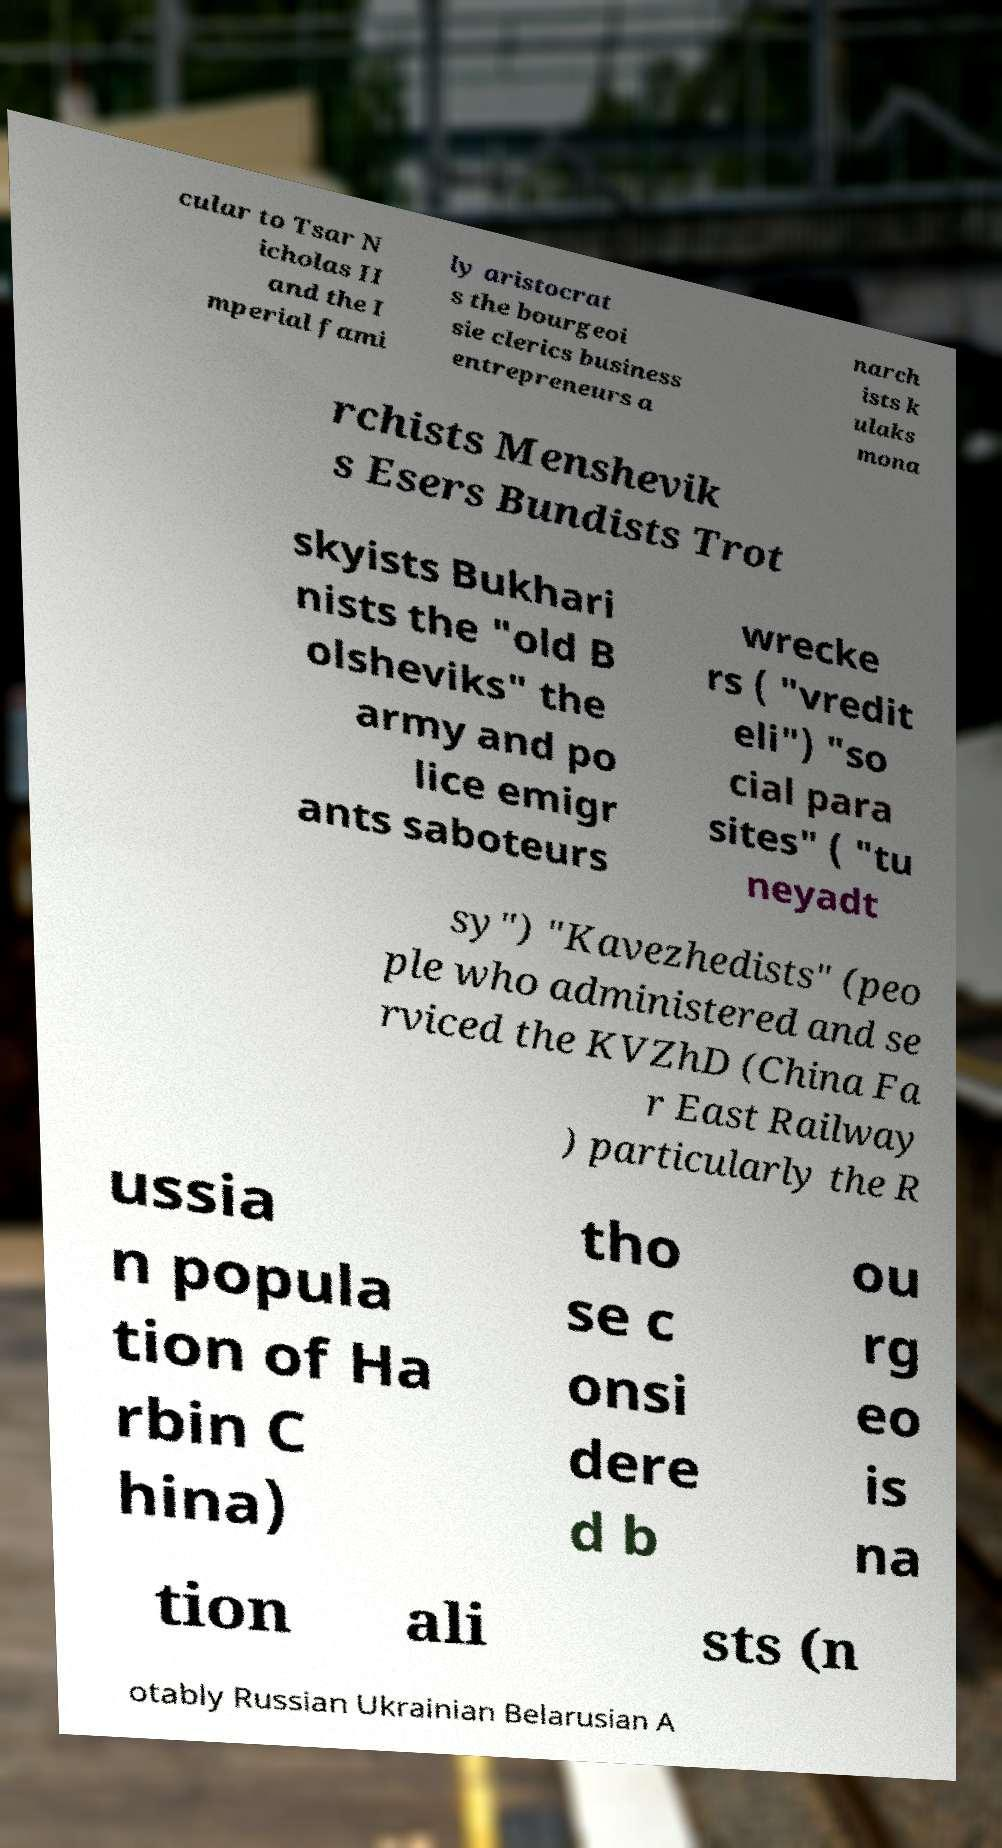What messages or text are displayed in this image? I need them in a readable, typed format. cular to Tsar N icholas II and the I mperial fami ly aristocrat s the bourgeoi sie clerics business entrepreneurs a narch ists k ulaks mona rchists Menshevik s Esers Bundists Trot skyists Bukhari nists the "old B olsheviks" the army and po lice emigr ants saboteurs wrecke rs ( "vredit eli") "so cial para sites" ( "tu neyadt sy") "Kavezhedists" (peo ple who administered and se rviced the KVZhD (China Fa r East Railway ) particularly the R ussia n popula tion of Ha rbin C hina) tho se c onsi dere d b ou rg eo is na tion ali sts (n otably Russian Ukrainian Belarusian A 